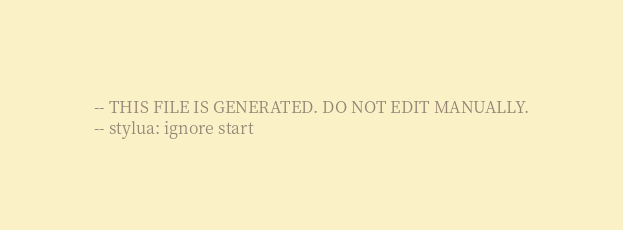<code> <loc_0><loc_0><loc_500><loc_500><_Lua_>-- THIS FILE IS GENERATED. DO NOT EDIT MANUALLY.
-- stylua: ignore start</code> 